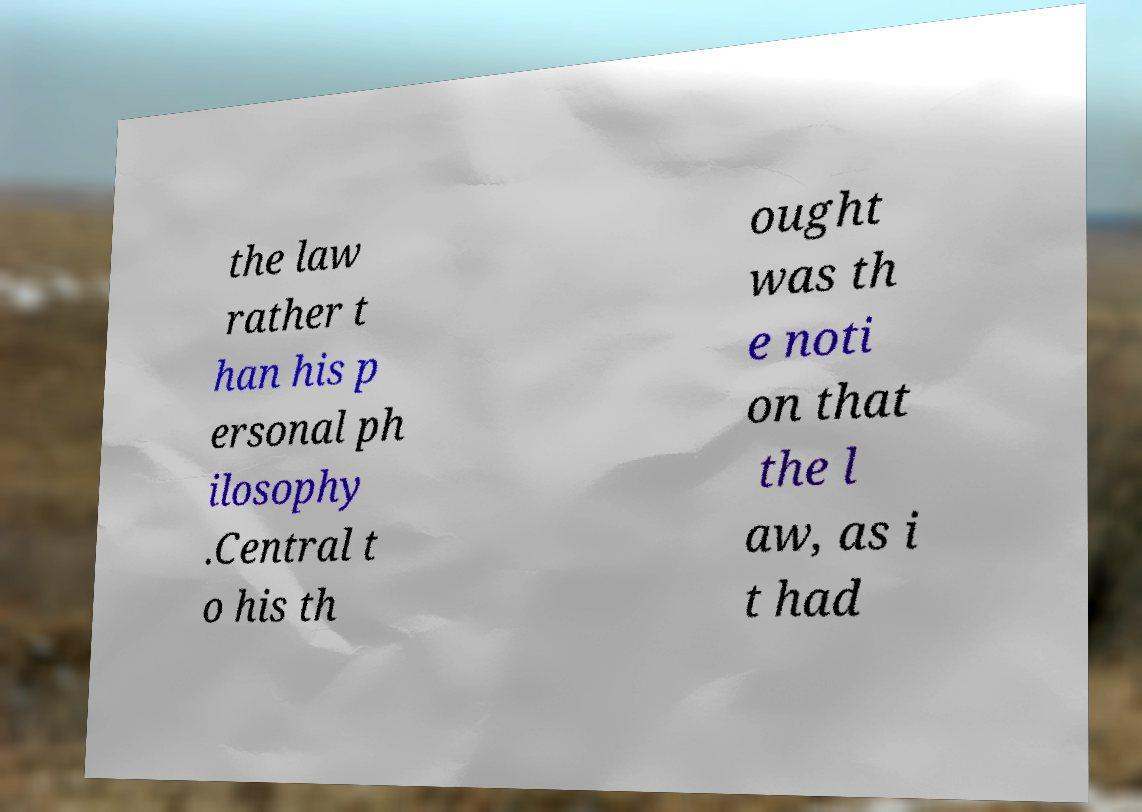For documentation purposes, I need the text within this image transcribed. Could you provide that? the law rather t han his p ersonal ph ilosophy .Central t o his th ought was th e noti on that the l aw, as i t had 